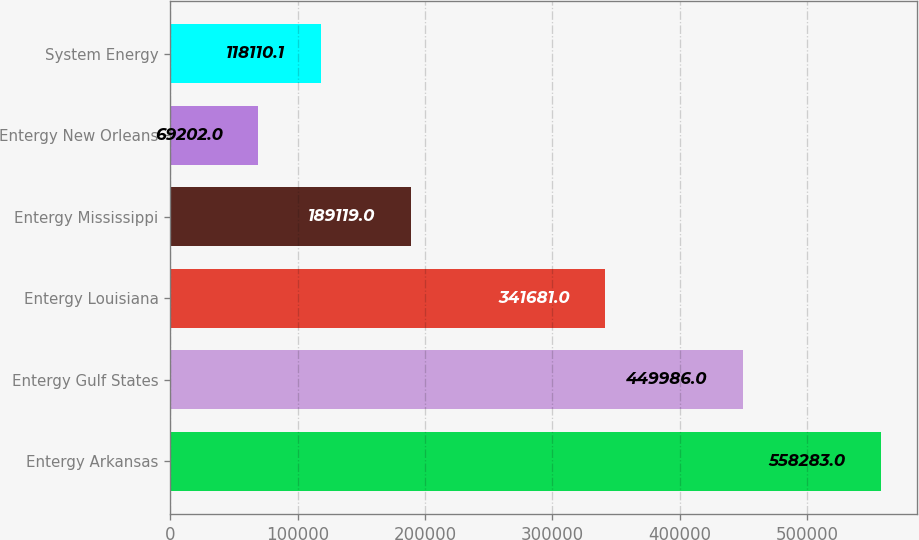Convert chart to OTSL. <chart><loc_0><loc_0><loc_500><loc_500><bar_chart><fcel>Entergy Arkansas<fcel>Entergy Gulf States<fcel>Entergy Louisiana<fcel>Entergy Mississippi<fcel>Entergy New Orleans<fcel>System Energy<nl><fcel>558283<fcel>449986<fcel>341681<fcel>189119<fcel>69202<fcel>118110<nl></chart> 